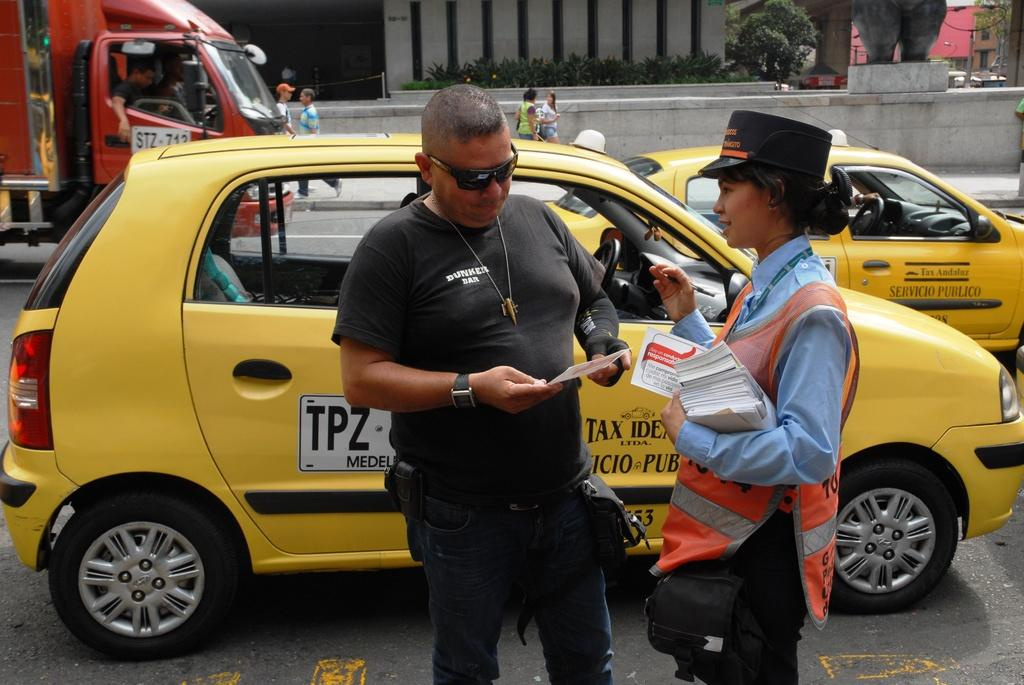Provide a one-sentence caption for the provided image. The guy is wear a black t-shirt saying 'Dunker Bar'. 